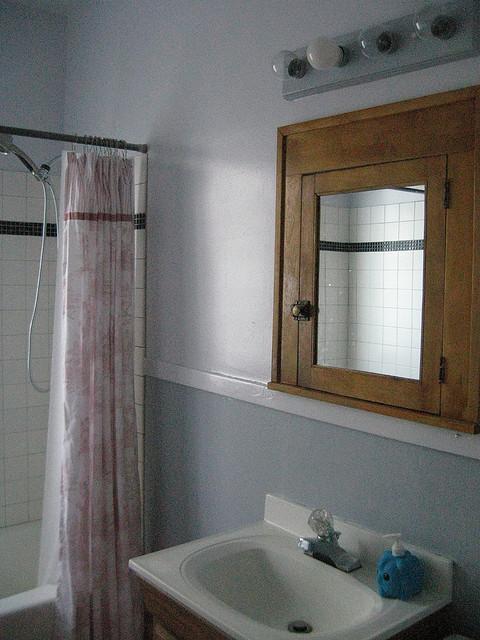How many sinks can you see?
Give a very brief answer. 1. 